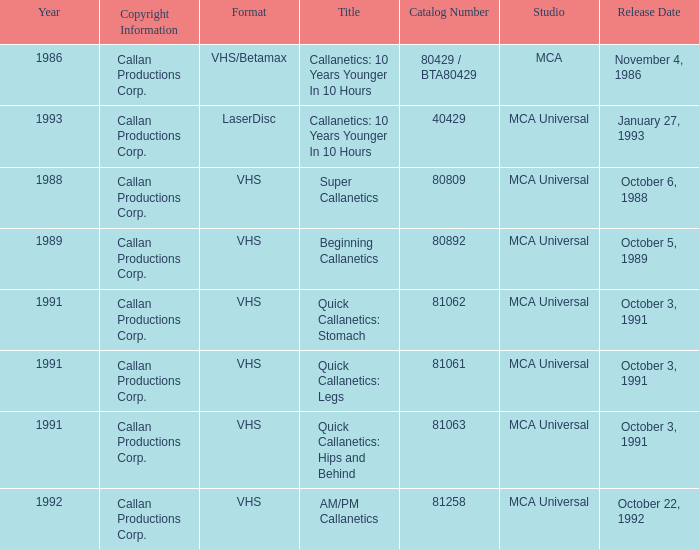Name the format for super callanetics VHS. 